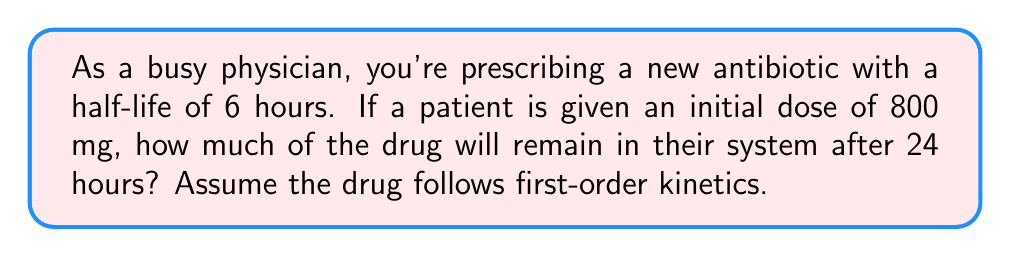Help me with this question. To solve this problem, we need to use the concept of half-life and exponential decay. The half-life is the time it takes for half of the drug to be eliminated from the body.

Let's break this down step-by-step:

1) The general formula for exponential decay is:

   $$A(t) = A_0 \cdot (1/2)^{t/t_{1/2}}$$

   Where:
   $A(t)$ is the amount remaining after time $t$
   $A_0$ is the initial amount
   $t$ is the time elapsed
   $t_{1/2}$ is the half-life

2) We're given:
   $A_0 = 800$ mg
   $t = 24$ hours
   $t_{1/2} = 6$ hours

3) Let's substitute these values into our formula:

   $$A(24) = 800 \cdot (1/2)^{24/6}$$

4) Simplify the exponent:
   
   $$A(24) = 800 \cdot (1/2)^4$$

5) Calculate:
   
   $$A(24) = 800 \cdot (1/16) = 50$$

Therefore, after 24 hours, 50 mg of the drug will remain in the patient's system.
Answer: 50 mg 